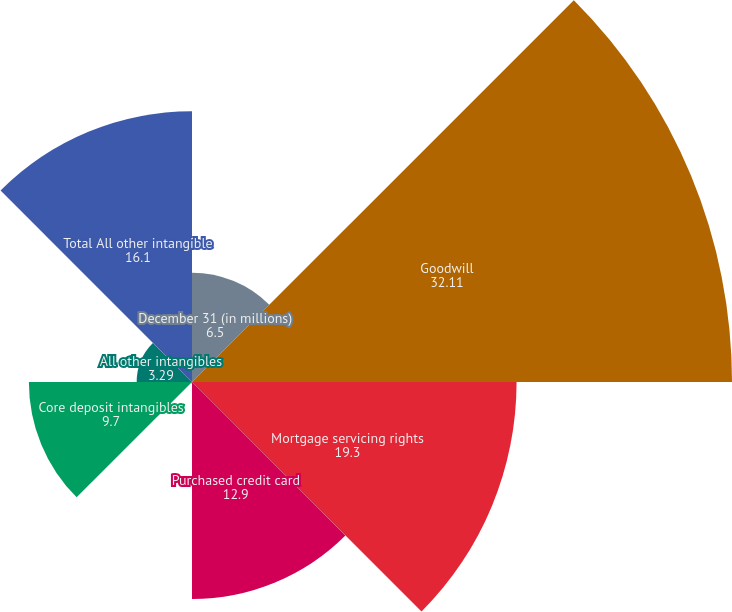Convert chart to OTSL. <chart><loc_0><loc_0><loc_500><loc_500><pie_chart><fcel>December 31 (in millions)<fcel>Goodwill<fcel>Mortgage servicing rights<fcel>Purchased credit card<fcel>Other credit card-related<fcel>Core deposit intangibles<fcel>All other intangibles<fcel>Total All other intangible<nl><fcel>6.5%<fcel>32.11%<fcel>19.3%<fcel>12.9%<fcel>0.09%<fcel>9.7%<fcel>3.29%<fcel>16.1%<nl></chart> 